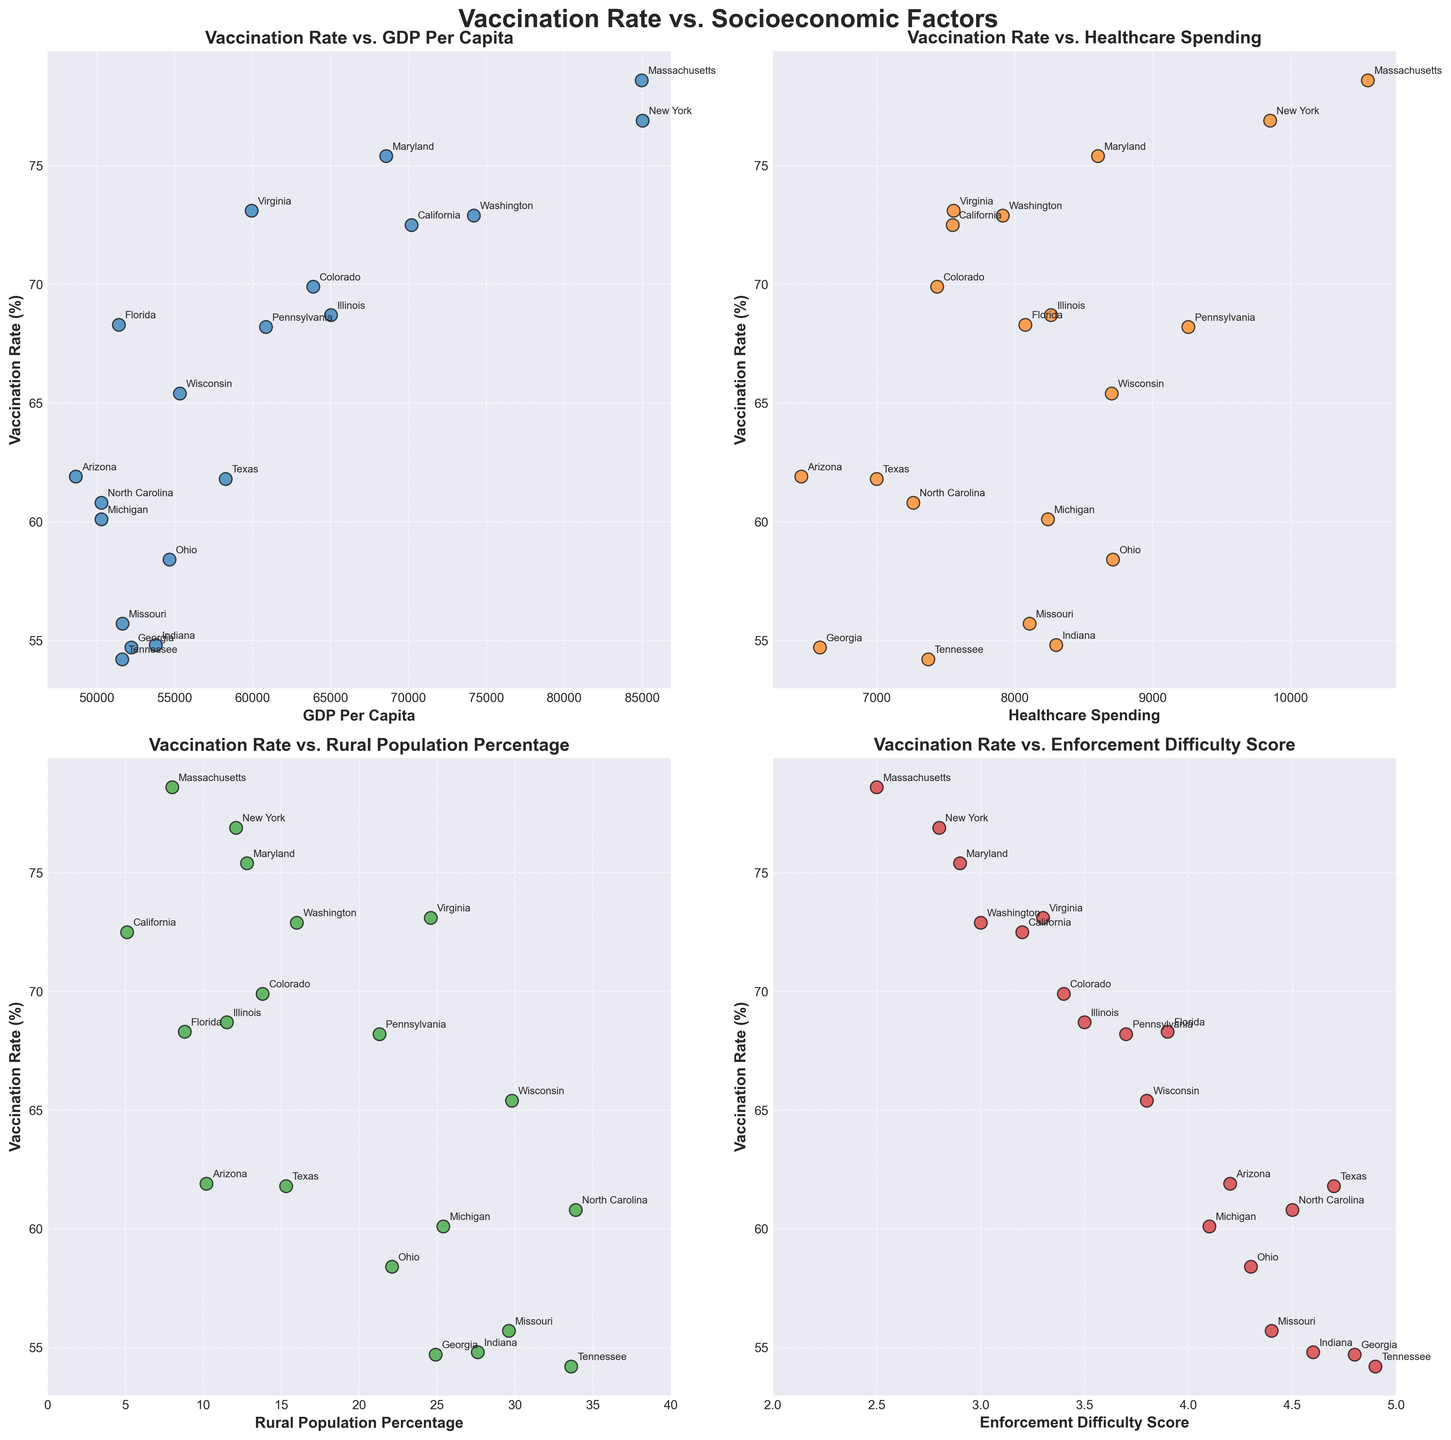What's the title of the subplot? The largest text at the top of the subplot is the title, "Vaccination Rate vs. Socioeconomic Factors".
Answer: Vaccination Rate vs. Socioeconomic Factors How many scatter plots are there in the figure? There are 4 separate scatter plots visible in the figure, each representing a different socioeconomic factor in relation to vaccination rates.
Answer: 4 Which state has the highest vaccination rate? By scanning the y-axis (Vaccination Rate) of all scatter plots, Massachusetts appears to have the highest vaccination rate of 78.6%.
Answer: Massachusetts Is there a correlation between Rural Population Percentage and Vaccination Rate? Observing the scatter plot labeled "Rural Population Percentage," there is no obvious trend or correlation visible; points are scattered widely without a clear pattern.
Answer: No How are Vaccination Rates generally distributed with respect to GDP Per Capita? Examining the scatter plot for "GDP Per Capita," states with higher GDP per capita, such as New York and Massachusetts, tend to have higher vaccination rates, suggesting a positive correlation.
Answer: Positively correlated Which factor appears to have the least variation in Vaccination Rates across different states? On comparing the scatter plots, "Enforcement Difficulty Score" seems to show the least variation in Vaccination Rates across states, as the points are more evenly spread close to each other compared to the other factors.
Answer: Enforcement Difficulty Score Which state has the highest healthcare spending and what is its vaccination rate? Observing the axis labeled "Healthcare Spending," Massachusetts has the highest spending at 10559. Its corresponding vaccination rate can be seen to be 78.6%.
Answer: Massachusetts, 78.6% What is the general trend between Enforcement Difficulty Score and Vaccination Rate? From the scatter plot "Enforcement Difficulty Score," there seems to be an inverse relationship, where states with higher enforcement difficulty scores tend to have lower vaccination rates.
Answer: Inversely correlated Does California have a high or low enforcement difficulty score, and how does it compare to Texas? Looking at the scatter plot for "Enforcement Difficulty Score," California has a moderately low difficulty score of 3.2, whereas Texas has a higher score of 4.7.
Answer: Low; lower than Texas Which states have vaccination rates below 60% and what are their GDP per capita values? Observing the scatter plot for "GDP Per Capita," Georgia (54.7), Tennessee (54.2), Indiana (54.8), Missouri (55.7), and Ohio (58.4) have vaccination rates below 60%. Their GDP per capita values are 52225, 51625, 53788, 51652, and 54662, respectively.
Answer: Georgia (52225), Tennessee (51625), Indiana (53788), Missouri (51652), Ohio (54662) 